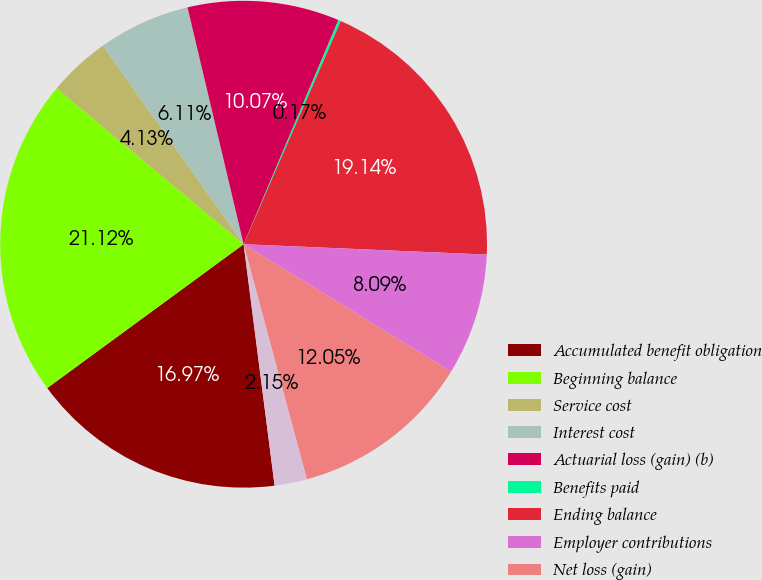Convert chart. <chart><loc_0><loc_0><loc_500><loc_500><pie_chart><fcel>Accumulated benefit obligation<fcel>Beginning balance<fcel>Service cost<fcel>Interest cost<fcel>Actuarial loss (gain) (b)<fcel>Benefits paid<fcel>Ending balance<fcel>Employer contributions<fcel>Net loss (gain)<fcel>Prior service cost (credit)<nl><fcel>16.97%<fcel>21.12%<fcel>4.13%<fcel>6.11%<fcel>10.07%<fcel>0.17%<fcel>19.14%<fcel>8.09%<fcel>12.05%<fcel>2.15%<nl></chart> 